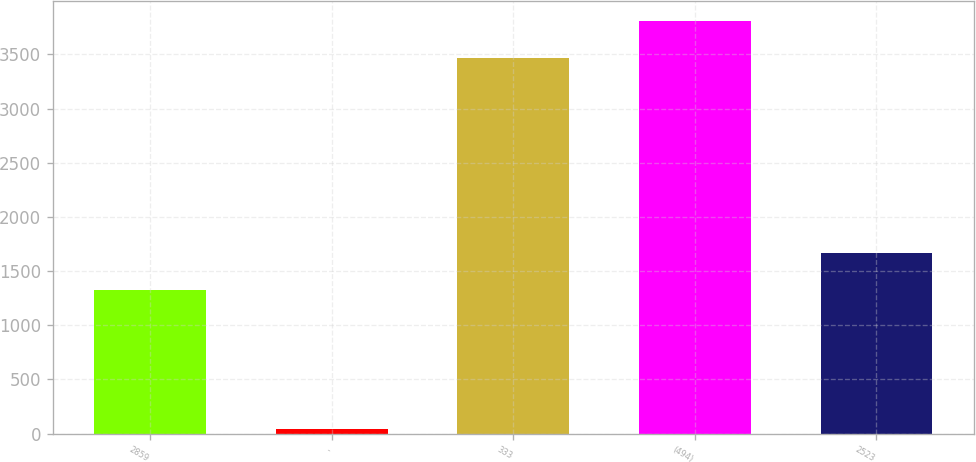Convert chart to OTSL. <chart><loc_0><loc_0><loc_500><loc_500><bar_chart><fcel>2859<fcel>-<fcel>333<fcel>(494)<fcel>2523<nl><fcel>1321<fcel>42<fcel>3462<fcel>3805.5<fcel>1664.5<nl></chart> 